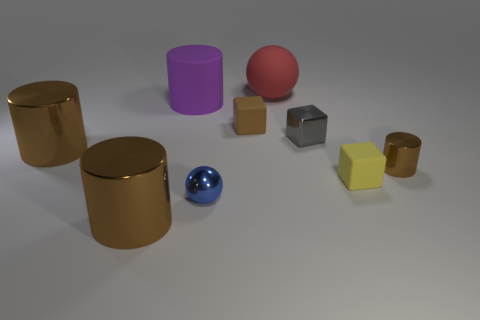The small object that is the same color as the tiny metallic cylinder is what shape?
Ensure brevity in your answer.  Cube. What number of blue objects are either tiny metallic objects or tiny matte objects?
Keep it short and to the point. 1. What number of other objects are there of the same shape as the large purple matte object?
Ensure brevity in your answer.  3. What shape is the shiny object that is left of the tiny blue ball and in front of the small yellow object?
Provide a succinct answer. Cylinder. Are there any small matte cubes behind the blue shiny thing?
Provide a succinct answer. Yes. What size is the red matte thing that is the same shape as the small blue metallic object?
Provide a short and direct response. Large. Does the tiny gray object have the same shape as the small brown rubber object?
Offer a terse response. Yes. There is a rubber cube that is to the right of the small gray metallic block that is behind the small blue shiny sphere; how big is it?
Ensure brevity in your answer.  Small. There is another tiny rubber thing that is the same shape as the small yellow thing; what color is it?
Your response must be concise. Brown. How many rubber objects have the same color as the tiny cylinder?
Give a very brief answer. 1. 